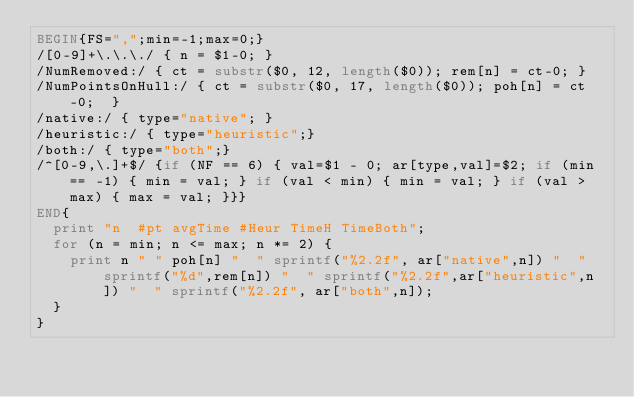Convert code to text. <code><loc_0><loc_0><loc_500><loc_500><_Awk_>BEGIN{FS=",";min=-1;max=0;}
/[0-9]+\.\.\./ { n = $1-0; }
/NumRemoved:/ { ct = substr($0, 12, length($0)); rem[n] = ct-0; }
/NumPointsOnHull:/ { ct = substr($0, 17, length($0)); poh[n] = ct-0;  }
/native:/ { type="native"; }
/heuristic:/ { type="heuristic";}
/both:/ { type="both";}
/^[0-9,\.]+$/ {if (NF == 6) { val=$1 - 0; ar[type,val]=$2; if (min == -1) { min = val; } if (val < min) { min = val; } if (val > max) { max = val; }}}
END{
  print "n	#pt	avgTime	#Heur	TimeH	TimeBoth";
  for (n = min; n <= max; n *= 2) {
    print n "	" poh[n] "	" sprintf("%2.2f", ar["native",n]) "	" sprintf("%d",rem[n]) "	" sprintf("%2.2f",ar["heuristic",n]) "	" sprintf("%2.2f", ar["both",n]);
  }
}</code> 